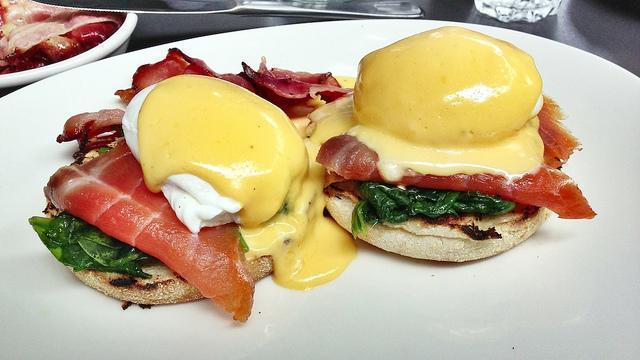How many knives can you see?
Give a very brief answer. 1. 